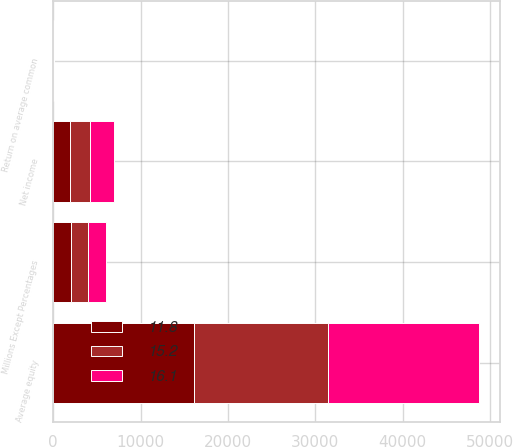Convert chart. <chart><loc_0><loc_0><loc_500><loc_500><stacked_bar_chart><ecel><fcel>Millions Except Percentages<fcel>Net income<fcel>Average equity<fcel>Return on average common<nl><fcel>16.1<fcel>2010<fcel>2780<fcel>17282<fcel>16.1<nl><fcel>11.8<fcel>2009<fcel>1890<fcel>16058<fcel>11.8<nl><fcel>15.2<fcel>2008<fcel>2335<fcel>15386<fcel>15.2<nl></chart> 